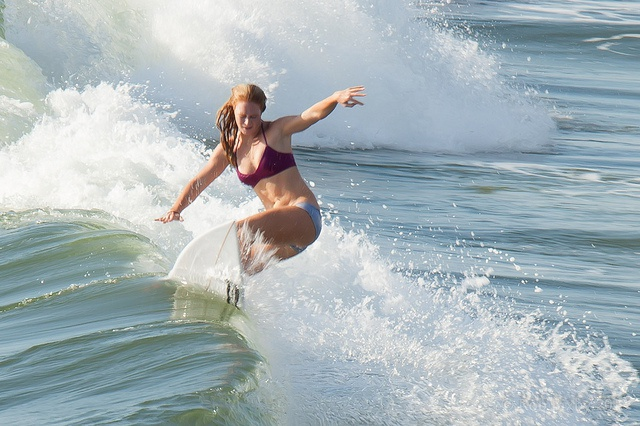Describe the objects in this image and their specific colors. I can see people in lightblue, gray, brown, lightgray, and tan tones and surfboard in darkgray, lightgray, and gray tones in this image. 